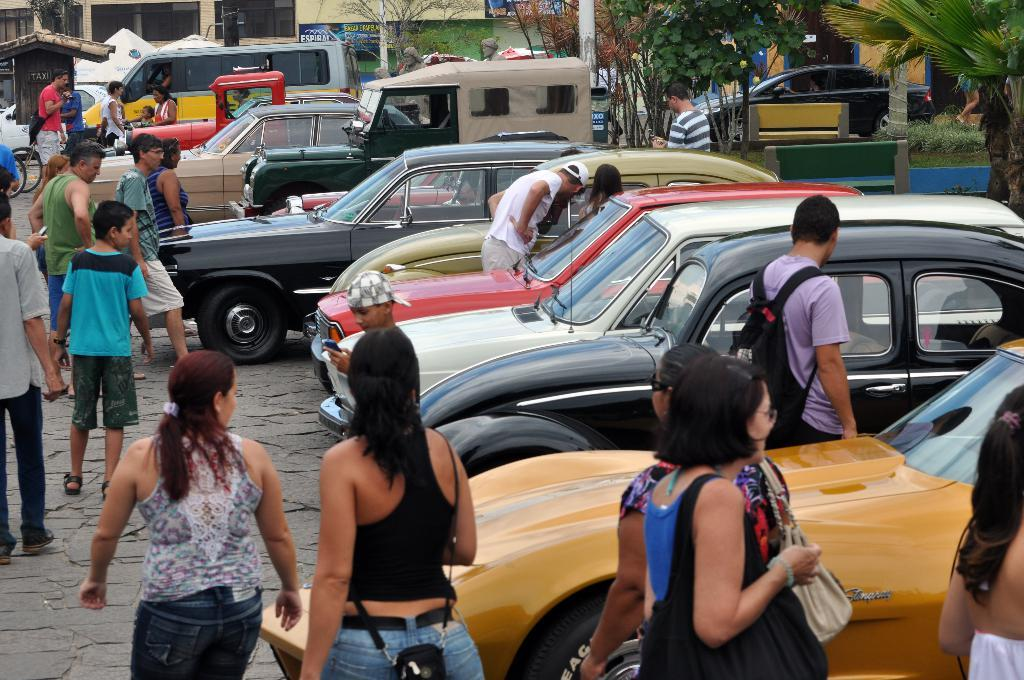What can be seen on the road in the image? There are vehicles on the road in the image. Who or what else is present in the image? There is a group of people in the image. What type of structures can be seen in the image? There are houses in the image. What other natural elements are visible in the image? There are trees in the image. Where is the chain located in the image? There is no chain present in the image. What discovery was made by the group of people in the image? There is no indication of a discovery being made by the group of people in the image. 